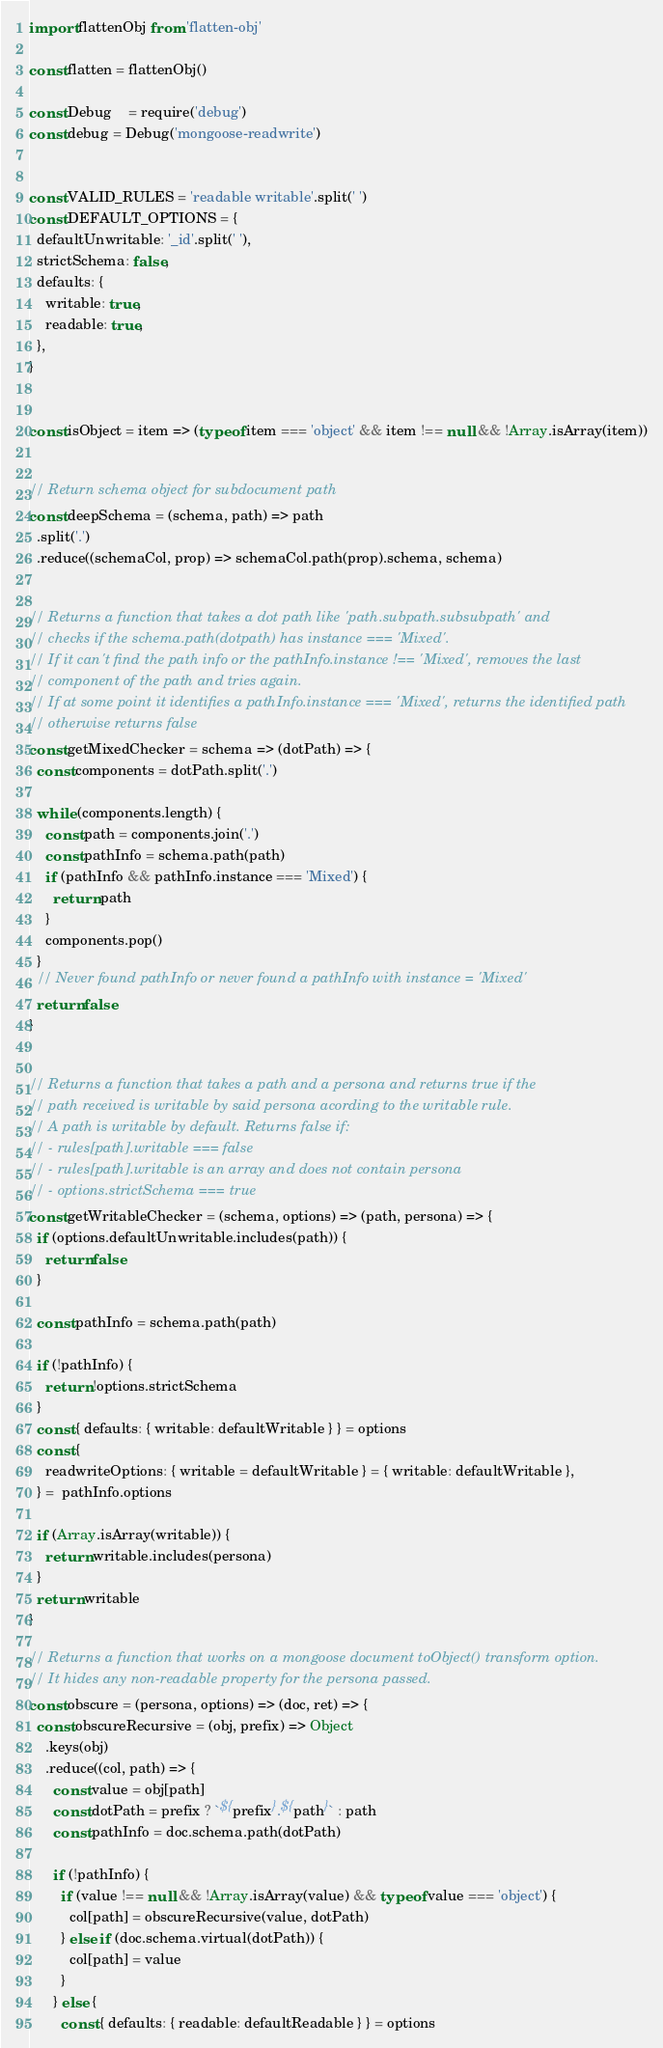<code> <loc_0><loc_0><loc_500><loc_500><_JavaScript_>import flattenObj from 'flatten-obj'

const flatten = flattenObj()

const Debug    = require('debug')
const debug = Debug('mongoose-readwrite')


const VALID_RULES = 'readable writable'.split(' ')
const DEFAULT_OPTIONS = {
  defaultUnwritable: '_id'.split(' '),
  strictSchema: false,
  defaults: {
    writable: true,
    readable: true,
  },
}


const isObject = item => (typeof item === 'object' && item !== null && !Array.isArray(item))


// Return schema object for subdocument path
const deepSchema = (schema, path) => path
  .split('.')
  .reduce((schemaCol, prop) => schemaCol.path(prop).schema, schema)


// Returns a function that takes a dot path like 'path.subpath.subsubpath' and
// checks if the schema.path(dotpath) has instance === 'Mixed'.
// If it can't find the path info or the pathInfo.instance !== 'Mixed', removes the last
// component of the path and tries again.
// If at some point it identifies a pathInfo.instance === 'Mixed', returns the identified path
// otherwise returns false
const getMixedChecker = schema => (dotPath) => {
  const components = dotPath.split('.')

  while (components.length) {
    const path = components.join('.')
    const pathInfo = schema.path(path)
    if (pathInfo && pathInfo.instance === 'Mixed') {
      return path
    }
    components.pop()
  }
  // Never found pathInfo or never found a pathInfo with instance = 'Mixed'
  return false
}


// Returns a function that takes a path and a persona and returns true if the
// path received is writable by said persona acording to the writable rule.
// A path is writable by default. Returns false if:
// - rules[path].writable === false
// - rules[path].writable is an array and does not contain persona
// - options.strictSchema === true
const getWritableChecker = (schema, options) => (path, persona) => {
  if (options.defaultUnwritable.includes(path)) {
    return false
  }

  const pathInfo = schema.path(path)

  if (!pathInfo) {
    return !options.strictSchema
  }
  const { defaults: { writable: defaultWritable } } = options
  const {
    readwriteOptions: { writable = defaultWritable } = { writable: defaultWritable },
  } =  pathInfo.options

  if (Array.isArray(writable)) {
    return writable.includes(persona)
  }
  return writable
}

// Returns a function that works on a mongoose document toObject() transform option.
// It hides any non-readable property for the persona passed.
const obscure = (persona, options) => (doc, ret) => {
  const obscureRecursive = (obj, prefix) => Object
    .keys(obj)
    .reduce((col, path) => {
      const value = obj[path]
      const dotPath = prefix ? `${prefix}.${path}` : path
      const pathInfo = doc.schema.path(dotPath)

      if (!pathInfo) {
        if (value !== null && !Array.isArray(value) && typeof value === 'object') {
          col[path] = obscureRecursive(value, dotPath)
        } else if (doc.schema.virtual(dotPath)) {
          col[path] = value
        }
      } else {
        const { defaults: { readable: defaultReadable } } = options</code> 